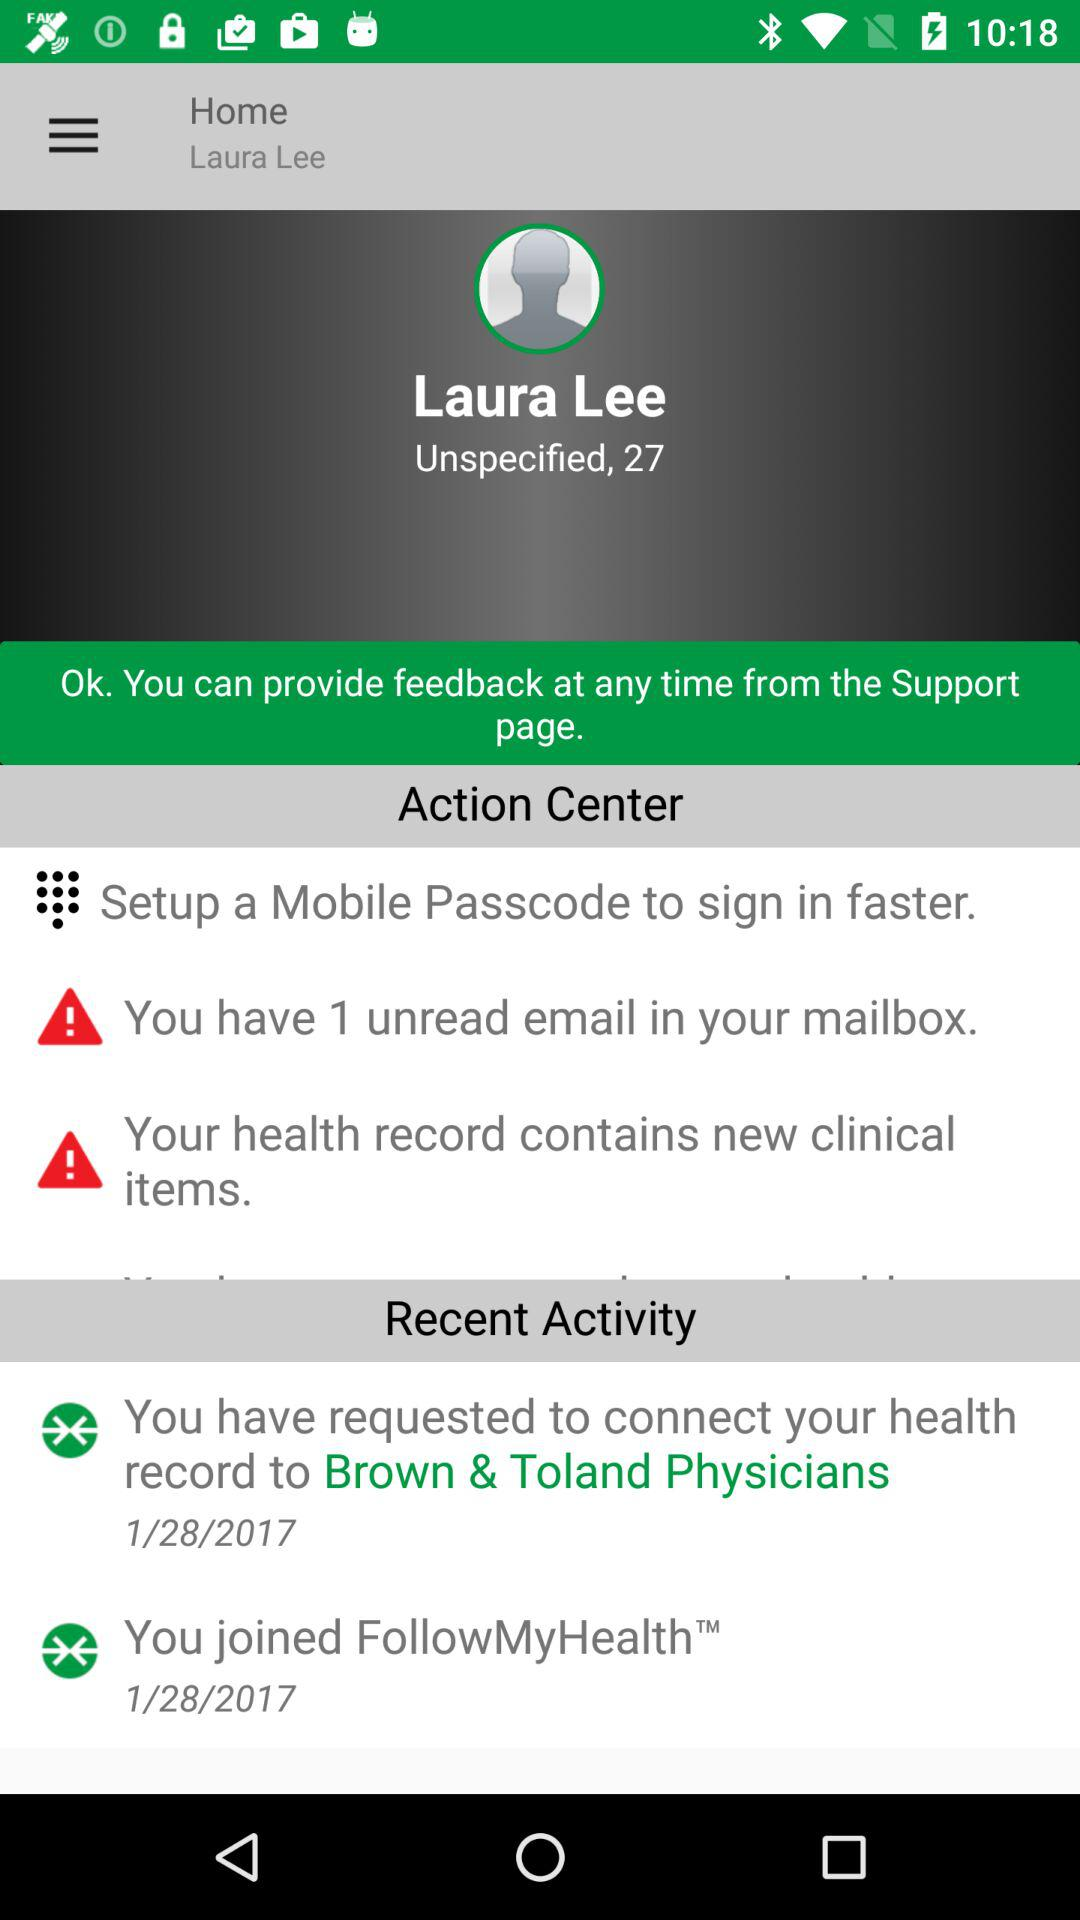On what date had I joined "FollowMyHealth"? You had joined "FollowMyHealth" on January 28, 2017. 